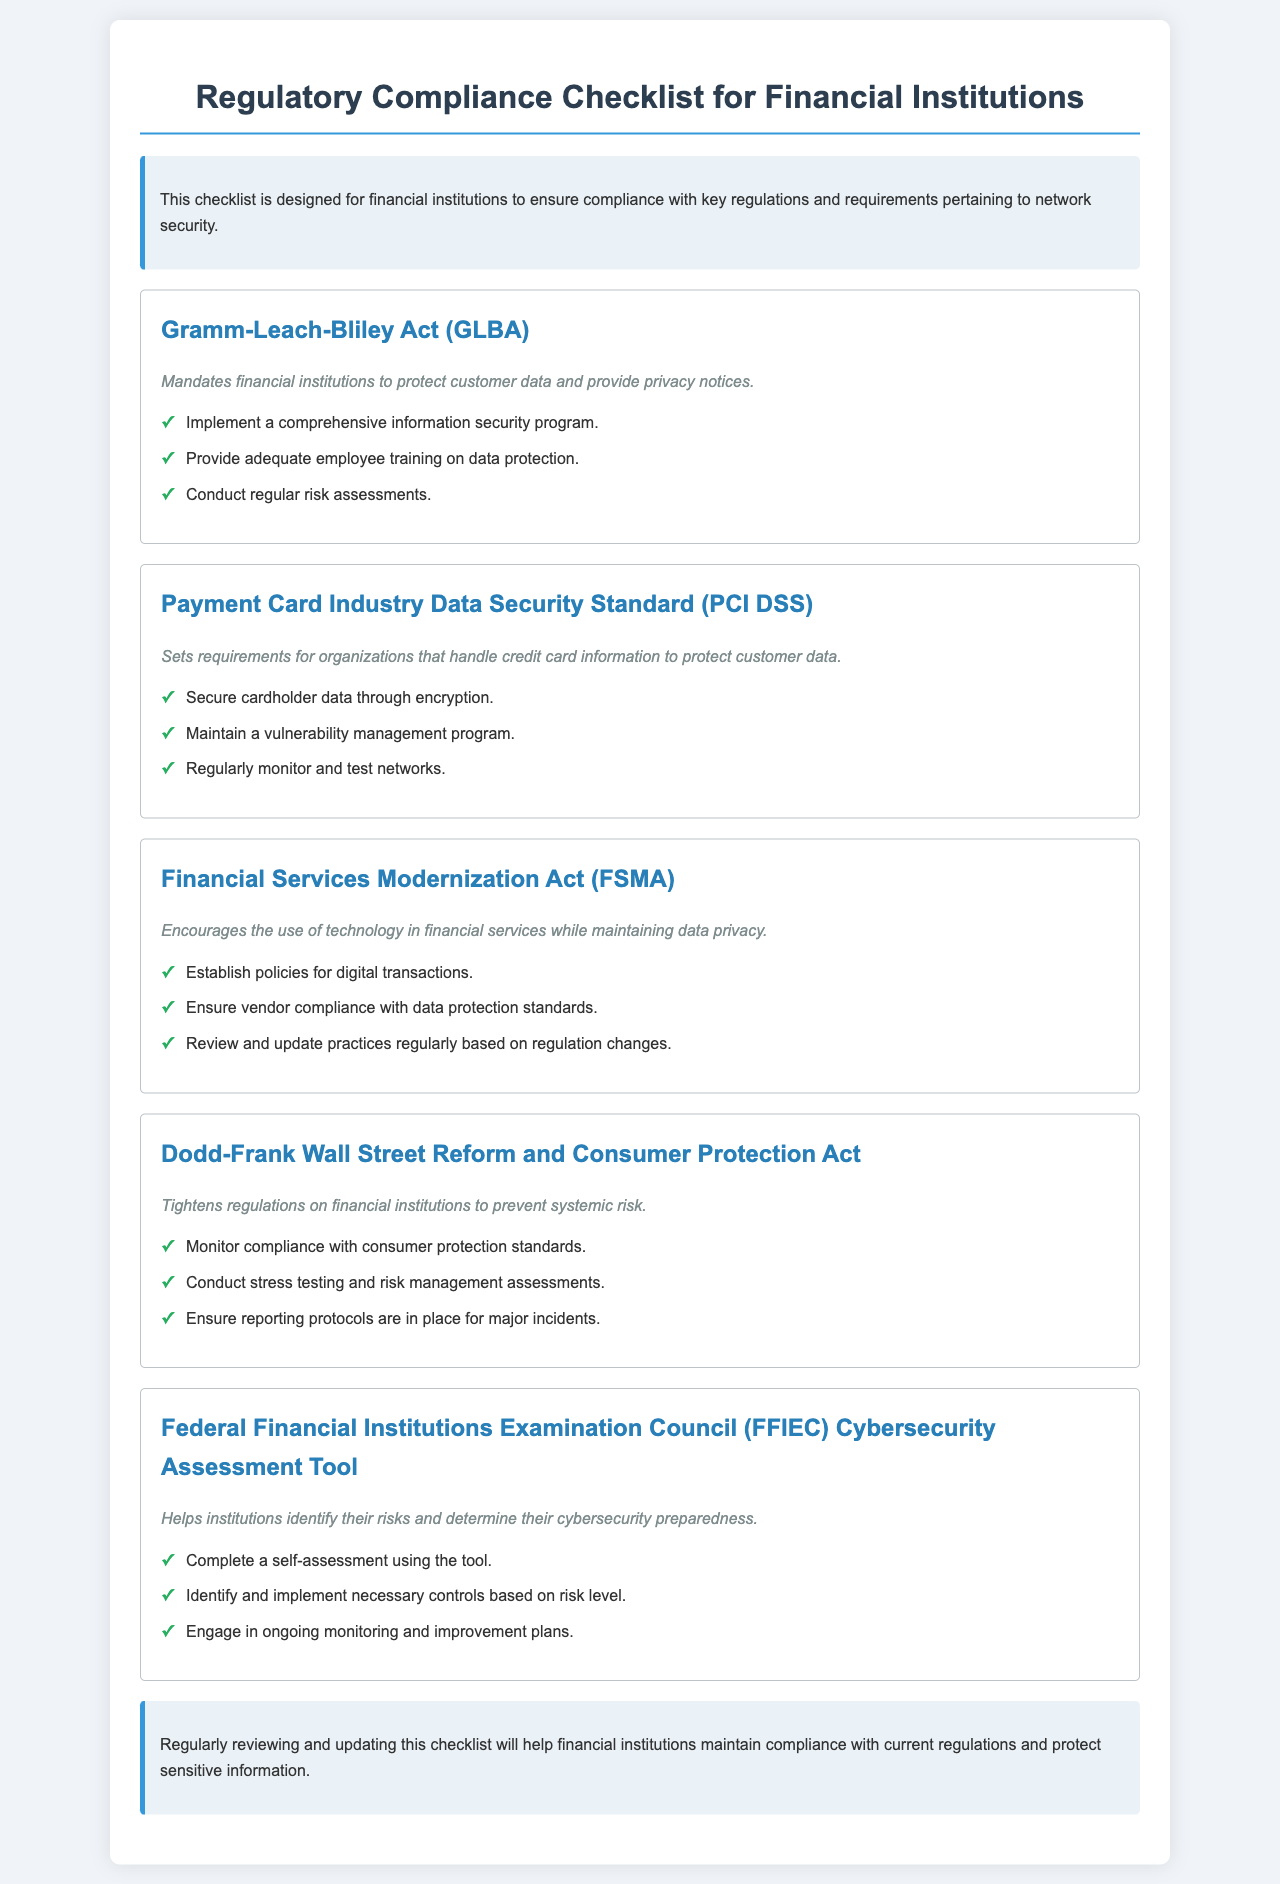What legislation mandates financial institutions to protect customer data? The question seeks to identify the specific legislation mentioned that relates to customer data protection.
Answer: Gramm-Leach-Bliley Act (GLBA) How many action items are listed under the Payment Card Industry Data Security Standard? The inquiry focuses on finding the total number of action items provided under the PCI DSS section.
Answer: Three What is the main purpose of the Financial Services Modernization Act? This question asks for a brief description of the primary aim of the FSMA as stated in the document.
Answer: Maintain data privacy Which regulation requires conducting stress testing? The question is aimed at identifying the regulation that involves stress testing as part of compliance measures.
Answer: Dodd-Frank Wall Street Reform and Consumer Protection Act What does the FFIEC Cybersecurity Assessment Tool help institutions to identify? This question asks about the specific benefit of using the FFIEC Cybersecurity Assessment Tool as outlined in the document.
Answer: Risks How many items are listed for the Gramm-Leach-Bliley Act? The question requests the count of action items associated with the GLBA.
Answer: Three What key aspect does the PCI DSS emphasize the security of? This question aims to pinpoint the focus area of the PCI DSS concerning data security.
Answer: Cardholder data What is advised to be conducted regularly to maintain compliance? The question looks for the recommended practice associated with compliance maintenance as stated in the conclusion.
Answer: Reviewing the checklist 